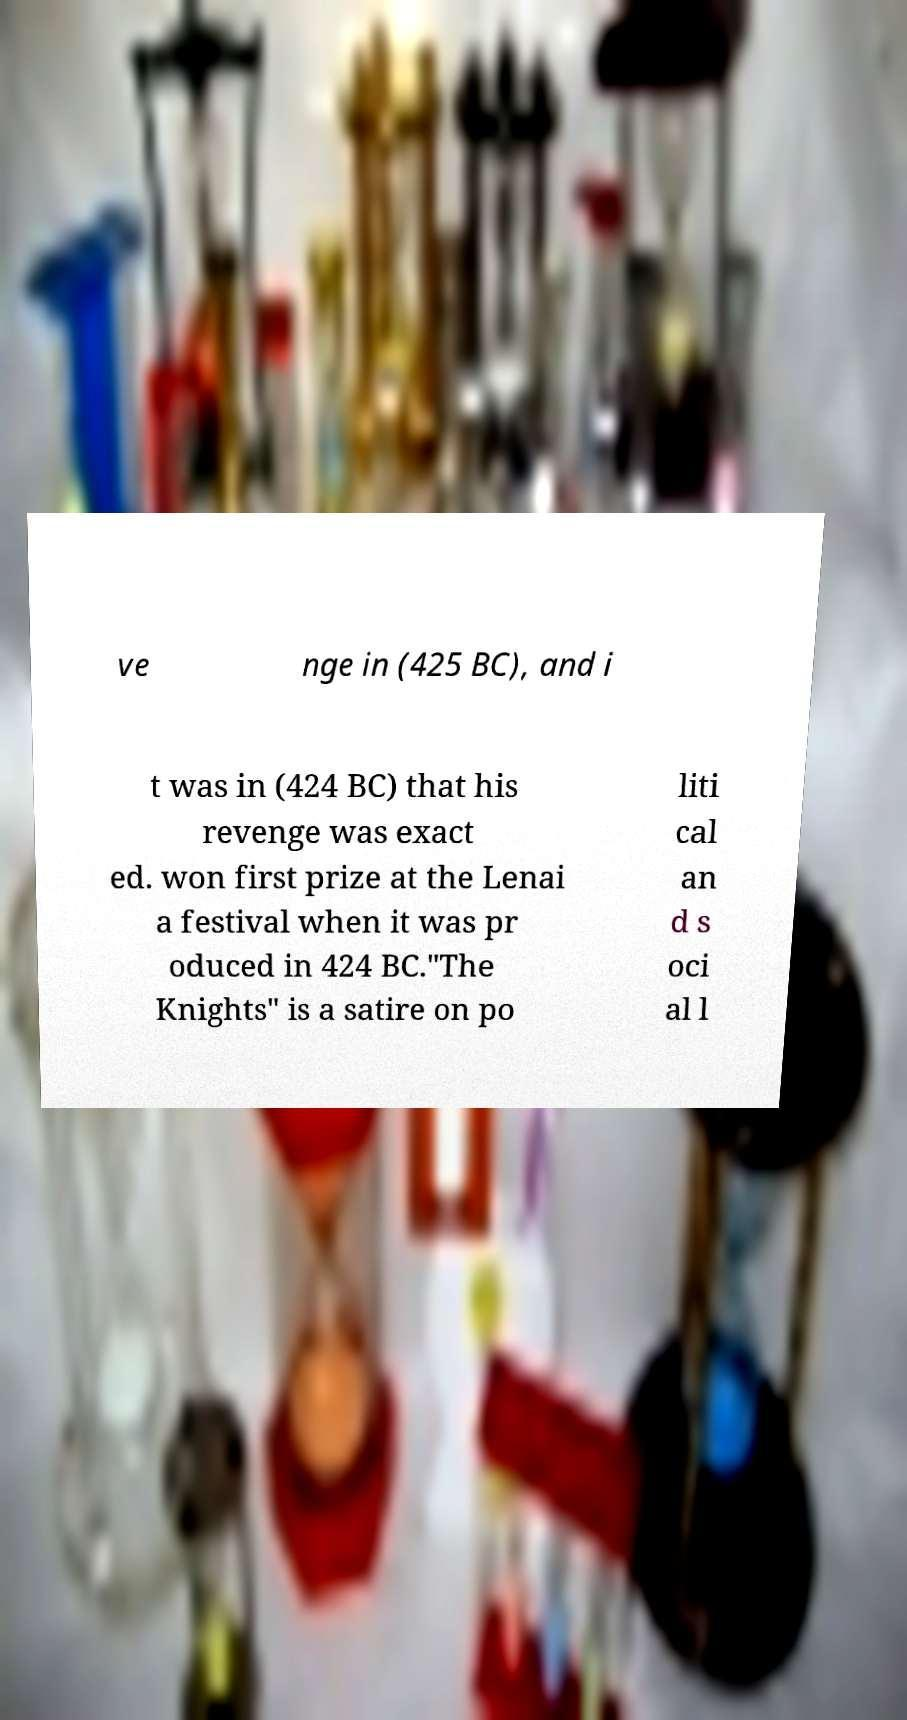Could you assist in decoding the text presented in this image and type it out clearly? ve nge in (425 BC), and i t was in (424 BC) that his revenge was exact ed. won first prize at the Lenai a festival when it was pr oduced in 424 BC."The Knights" is a satire on po liti cal an d s oci al l 